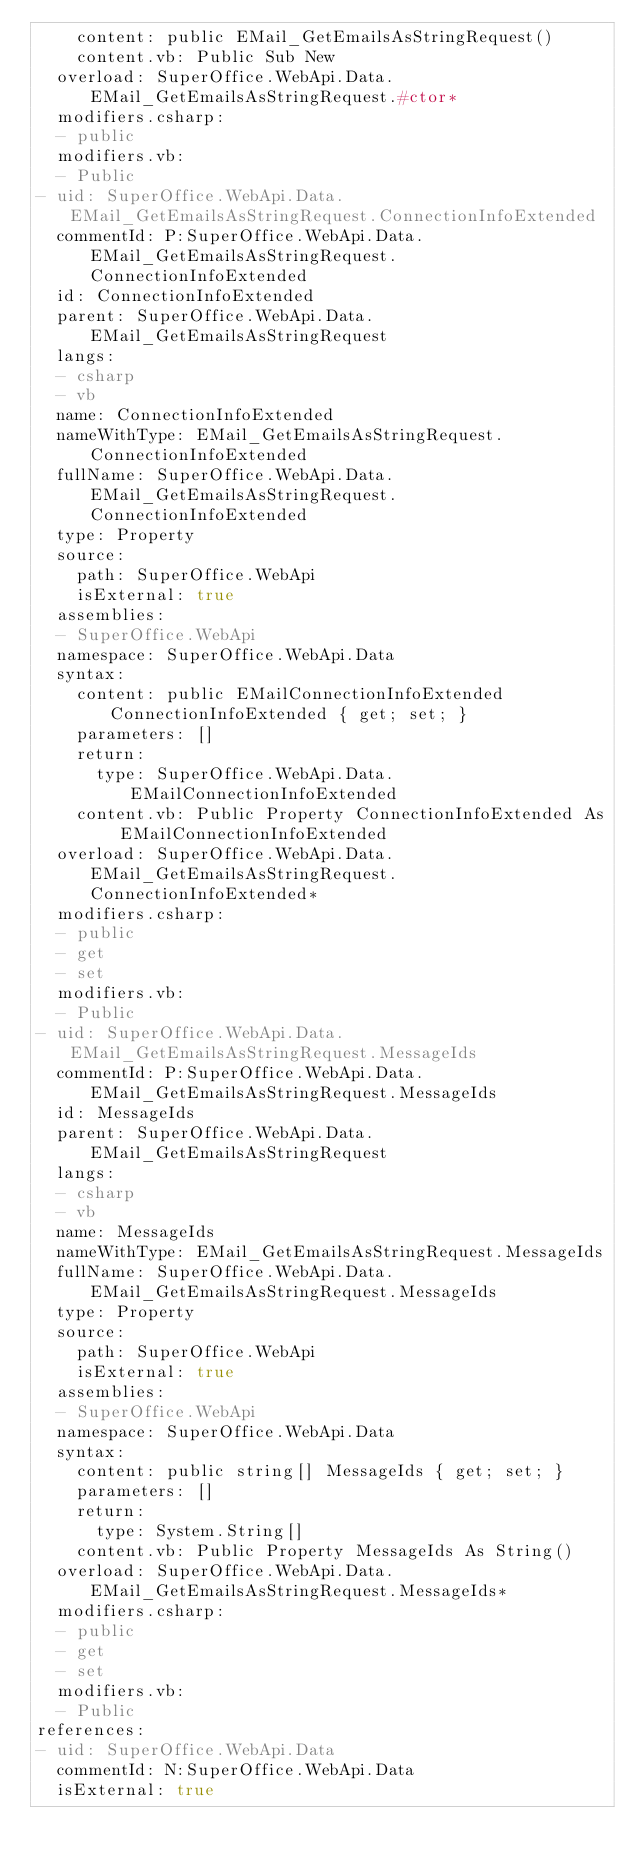Convert code to text. <code><loc_0><loc_0><loc_500><loc_500><_YAML_>    content: public EMail_GetEmailsAsStringRequest()
    content.vb: Public Sub New
  overload: SuperOffice.WebApi.Data.EMail_GetEmailsAsStringRequest.#ctor*
  modifiers.csharp:
  - public
  modifiers.vb:
  - Public
- uid: SuperOffice.WebApi.Data.EMail_GetEmailsAsStringRequest.ConnectionInfoExtended
  commentId: P:SuperOffice.WebApi.Data.EMail_GetEmailsAsStringRequest.ConnectionInfoExtended
  id: ConnectionInfoExtended
  parent: SuperOffice.WebApi.Data.EMail_GetEmailsAsStringRequest
  langs:
  - csharp
  - vb
  name: ConnectionInfoExtended
  nameWithType: EMail_GetEmailsAsStringRequest.ConnectionInfoExtended
  fullName: SuperOffice.WebApi.Data.EMail_GetEmailsAsStringRequest.ConnectionInfoExtended
  type: Property
  source:
    path: SuperOffice.WebApi
    isExternal: true
  assemblies:
  - SuperOffice.WebApi
  namespace: SuperOffice.WebApi.Data
  syntax:
    content: public EMailConnectionInfoExtended ConnectionInfoExtended { get; set; }
    parameters: []
    return:
      type: SuperOffice.WebApi.Data.EMailConnectionInfoExtended
    content.vb: Public Property ConnectionInfoExtended As EMailConnectionInfoExtended
  overload: SuperOffice.WebApi.Data.EMail_GetEmailsAsStringRequest.ConnectionInfoExtended*
  modifiers.csharp:
  - public
  - get
  - set
  modifiers.vb:
  - Public
- uid: SuperOffice.WebApi.Data.EMail_GetEmailsAsStringRequest.MessageIds
  commentId: P:SuperOffice.WebApi.Data.EMail_GetEmailsAsStringRequest.MessageIds
  id: MessageIds
  parent: SuperOffice.WebApi.Data.EMail_GetEmailsAsStringRequest
  langs:
  - csharp
  - vb
  name: MessageIds
  nameWithType: EMail_GetEmailsAsStringRequest.MessageIds
  fullName: SuperOffice.WebApi.Data.EMail_GetEmailsAsStringRequest.MessageIds
  type: Property
  source:
    path: SuperOffice.WebApi
    isExternal: true
  assemblies:
  - SuperOffice.WebApi
  namespace: SuperOffice.WebApi.Data
  syntax:
    content: public string[] MessageIds { get; set; }
    parameters: []
    return:
      type: System.String[]
    content.vb: Public Property MessageIds As String()
  overload: SuperOffice.WebApi.Data.EMail_GetEmailsAsStringRequest.MessageIds*
  modifiers.csharp:
  - public
  - get
  - set
  modifiers.vb:
  - Public
references:
- uid: SuperOffice.WebApi.Data
  commentId: N:SuperOffice.WebApi.Data
  isExternal: true</code> 